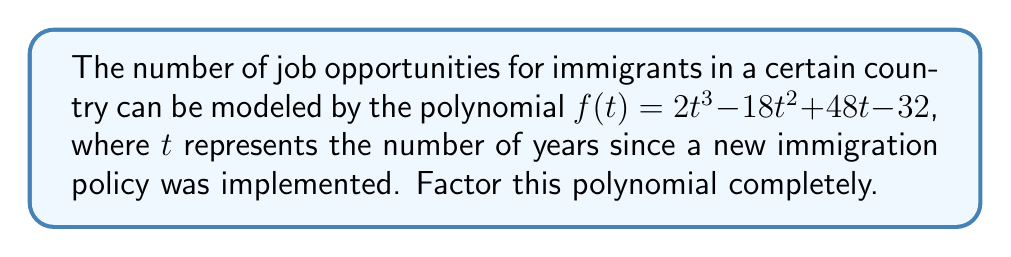Provide a solution to this math problem. Let's approach this step-by-step:

1) First, we should check if there's a common factor for all terms:
   $2t^3 - 18t^2 + 48t - 32$
   There's no common factor, so we proceed to the next step.

2) This is a cubic polynomial. One method to factor it is to guess one root and then use polynomial long division.

3) Let's try some potential roots. The possible rational roots are factors of the constant term 32: ±1, ±2, ±4, ±8, ±16, ±32

4) Testing these, we find that $t = 2$ is a root. So $(t - 2)$ is a factor.

5) Let's use polynomial long division to divide $f(t)$ by $(t - 2)$:

   $$\begin{array}{r}
   2t^2 - 14t + 20 \\
   t - 2 \enclose{longdiv}{2t^3 - 18t^2 + 48t - 32} \\
   \underline{2t^3 - 4t^2} \\
   -14t^2 + 48t \\
   \underline{-14t^2 + 28t} \\
   20t - 32 \\
   \underline{20t - 40} \\
   8
   \end{array}$$

6) So, $f(t) = (t - 2)(2t^2 - 14t + 20)$

7) Now we need to factor $2t^2 - 14t + 20$. This is a quadratic equation.

8) We can factor this using the ac-method:
   $2t^2 - 14t + 20 = 2t^2 - 10t - 4t + 20 = 2t(t - 5) - 4(t - 5) = (2t - 4)(t - 5)$

9) Therefore, the complete factorization is:
   $f(t) = (t - 2)(2t - 4)(t - 5) = (t - 2)(2)(t - 2)(t - 5) = 2(t - 2)^2(t - 5)$
Answer: $2(t - 2)^2(t - 5)$ 